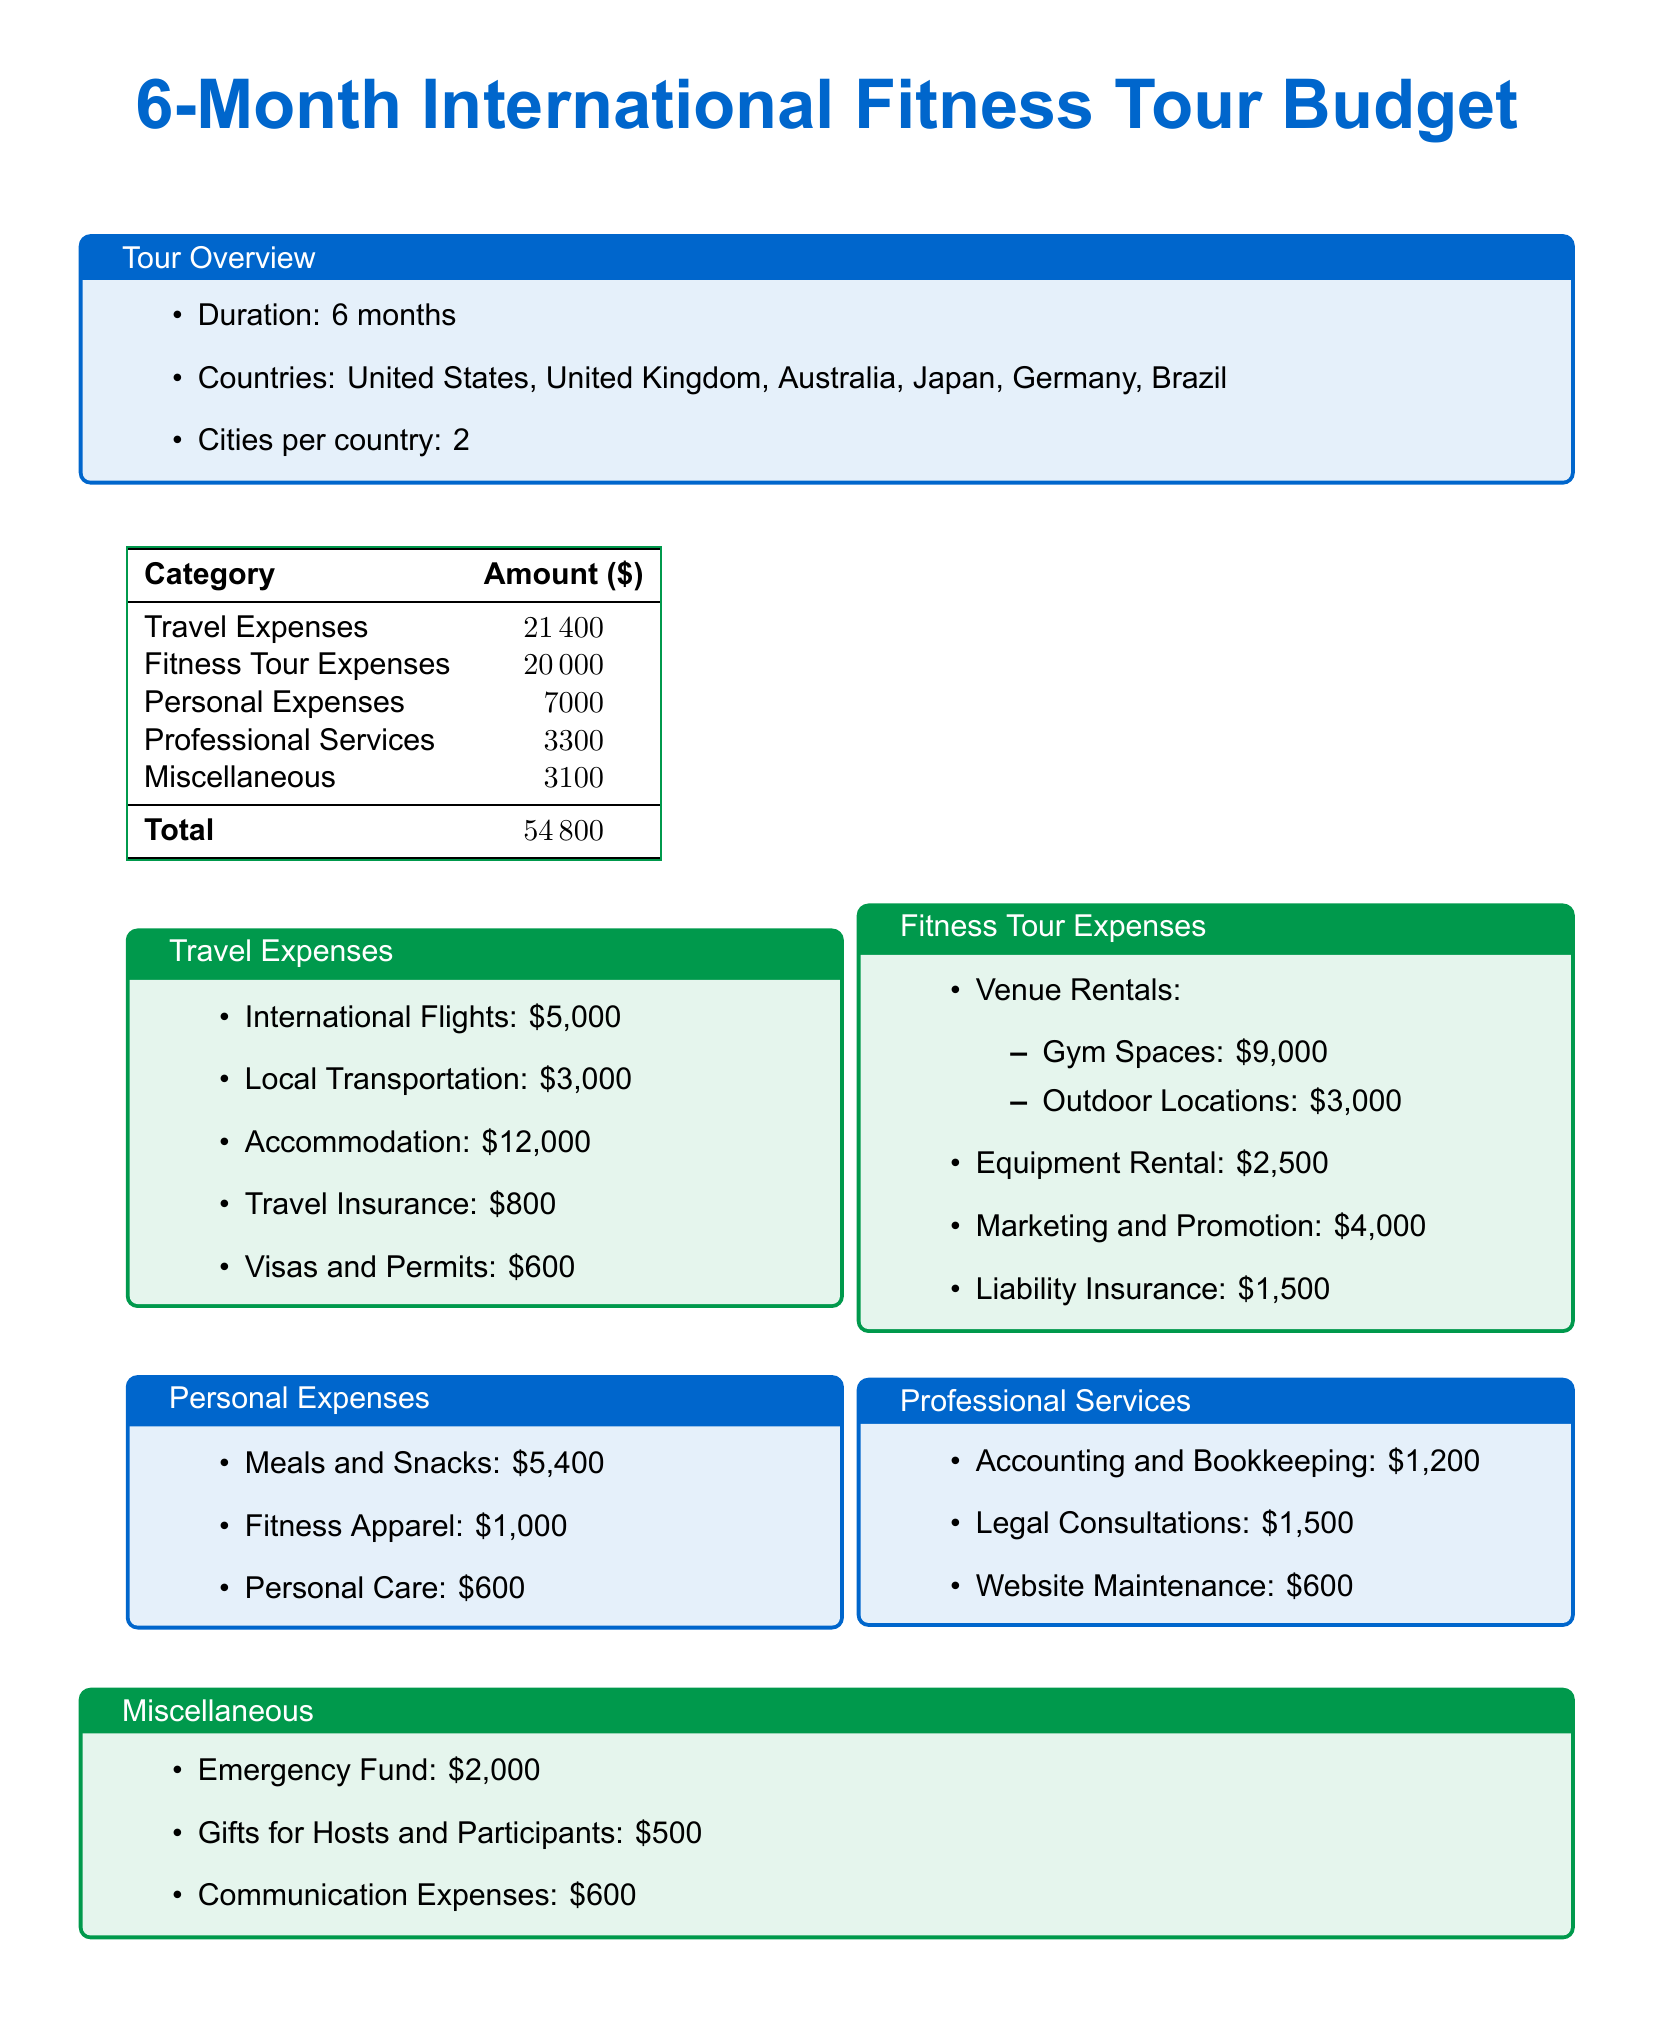what is the total budget for the tour? The total budget is the sum of all expenses listed in the document, which amounts to $21,400 + $20,000 + $7,000 + $3,300 + $3,100 = $54,800.
Answer: $54,800 how much is allocated for travel expenses? The travel expenses amount is explicitly provided in the document under the travel expenses section.
Answer: $21,400 how much will be spent on venue rentals? Venue rentals are specifically detailed, with gym spaces and outdoor locations combined amounting to $9,000 + $3,000.
Answer: $12,000 what is the total amount spent on personal expenses? The personal expenses comprise meals, fitness apparel, and personal care, which when added together total to $5,400 + $1,000 + $600.
Answer: $7,000 how much is budgeted for marketing and promotion? The budget for marketing and promotion is a specific value mentioned in the fitness tour expenses section of the document.
Answer: $4,000 what are the two categories of venue rentals? The document categorizes venue rentals into gym spaces and outdoor locations.
Answer: Gym Spaces and Outdoor Locations what is the cost of local transportation? The cost is explicitly stated in the travel expenses section.
Answer: $3,000 how much is allocated for liability insurance? The amount for liability insurance is listed under the fitness tour expenses category.
Answer: $1,500 what is included in the miscellaneous expenses? Miscellaneous expenses include an emergency fund, gifts for hosts and participants, and communication expenses.
Answer: Emergency Fund, Gifts for Hosts and Participants, Communication Expenses 